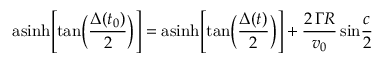<formula> <loc_0><loc_0><loc_500><loc_500>a \sinh \left [ t a n \left ( { \frac { \Delta ( t _ { 0 } ) } { 2 } } \right ) \right ] = a \sinh \left [ t a n \left ( { \frac { \Delta ( t ) } { 2 } } \right ) \right ] + { \frac { 2 \, \Gamma R } { v _ { 0 } } } \, \sin { \frac { c } { 2 } }</formula> 